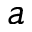<formula> <loc_0><loc_0><loc_500><loc_500>a</formula> 